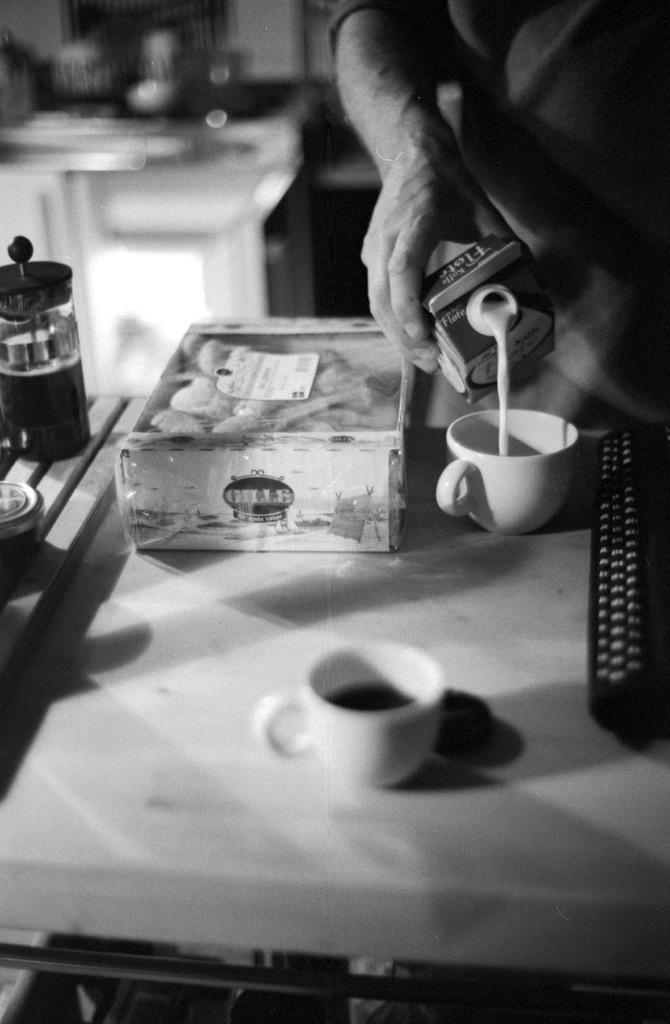Who or what is present in the image? There is a person in the image. What is the person holding in the image? The person is holding a box. Are there any other boxes visible in the image? Yes, there is another box in the image. How many cups can be seen in the image? There are 2 cups in the image. Can you see any pigs or ladybugs in the image? No, there are no pigs or ladybugs present in the image. Are there any wings visible in the image? No, there are no wings visible in the image. 